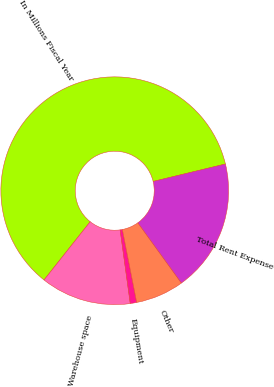Convert chart. <chart><loc_0><loc_0><loc_500><loc_500><pie_chart><fcel>In Millions Fiscal Year<fcel>Warehouse space<fcel>Equipment<fcel>Other<fcel>Total Rent Expense<nl><fcel>60.57%<fcel>12.84%<fcel>0.91%<fcel>6.87%<fcel>18.81%<nl></chart> 